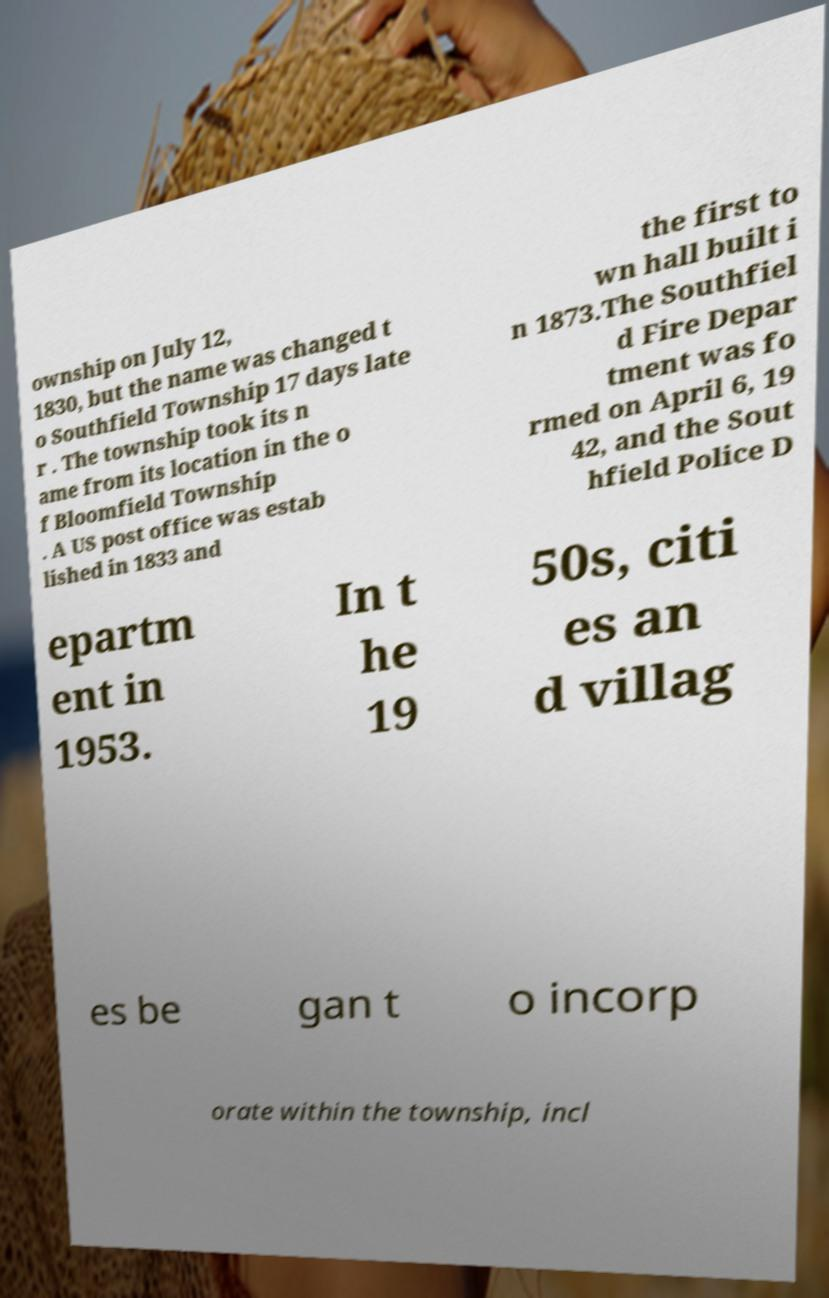Please identify and transcribe the text found in this image. ownship on July 12, 1830, but the name was changed t o Southfield Township 17 days late r . The township took its n ame from its location in the o f Bloomfield Township . A US post office was estab lished in 1833 and the first to wn hall built i n 1873.The Southfiel d Fire Depar tment was fo rmed on April 6, 19 42, and the Sout hfield Police D epartm ent in 1953. In t he 19 50s, citi es an d villag es be gan t o incorp orate within the township, incl 